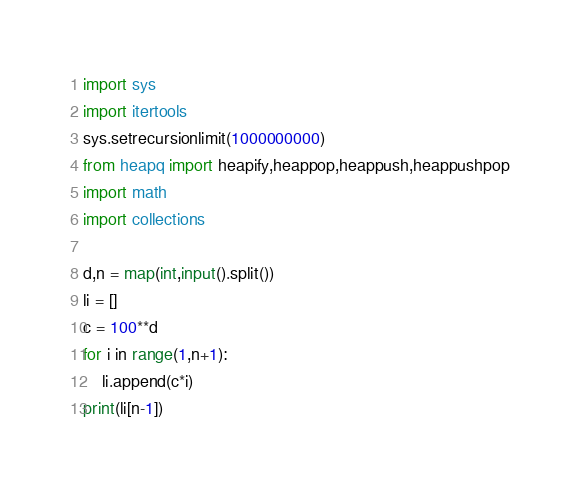<code> <loc_0><loc_0><loc_500><loc_500><_Python_>import sys
import itertools
sys.setrecursionlimit(1000000000)
from heapq import heapify,heappop,heappush,heappushpop
import math
import collections

d,n = map(int,input().split())
li = []
c = 100**d
for i in range(1,n+1):
    li.append(c*i)
print(li[n-1])</code> 